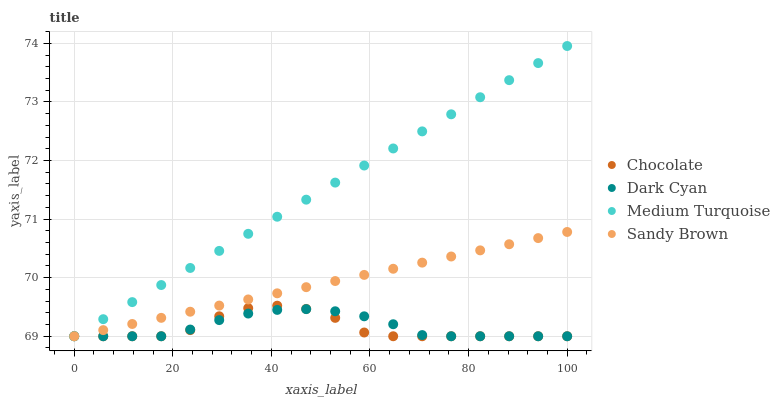Does Chocolate have the minimum area under the curve?
Answer yes or no. Yes. Does Medium Turquoise have the maximum area under the curve?
Answer yes or no. Yes. Does Sandy Brown have the minimum area under the curve?
Answer yes or no. No. Does Sandy Brown have the maximum area under the curve?
Answer yes or no. No. Is Sandy Brown the smoothest?
Answer yes or no. Yes. Is Chocolate the roughest?
Answer yes or no. Yes. Is Medium Turquoise the smoothest?
Answer yes or no. No. Is Medium Turquoise the roughest?
Answer yes or no. No. Does Dark Cyan have the lowest value?
Answer yes or no. Yes. Does Medium Turquoise have the highest value?
Answer yes or no. Yes. Does Sandy Brown have the highest value?
Answer yes or no. No. Does Chocolate intersect Dark Cyan?
Answer yes or no. Yes. Is Chocolate less than Dark Cyan?
Answer yes or no. No. Is Chocolate greater than Dark Cyan?
Answer yes or no. No. 